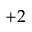Convert formula to latex. <formula><loc_0><loc_0><loc_500><loc_500>+ 2</formula> 